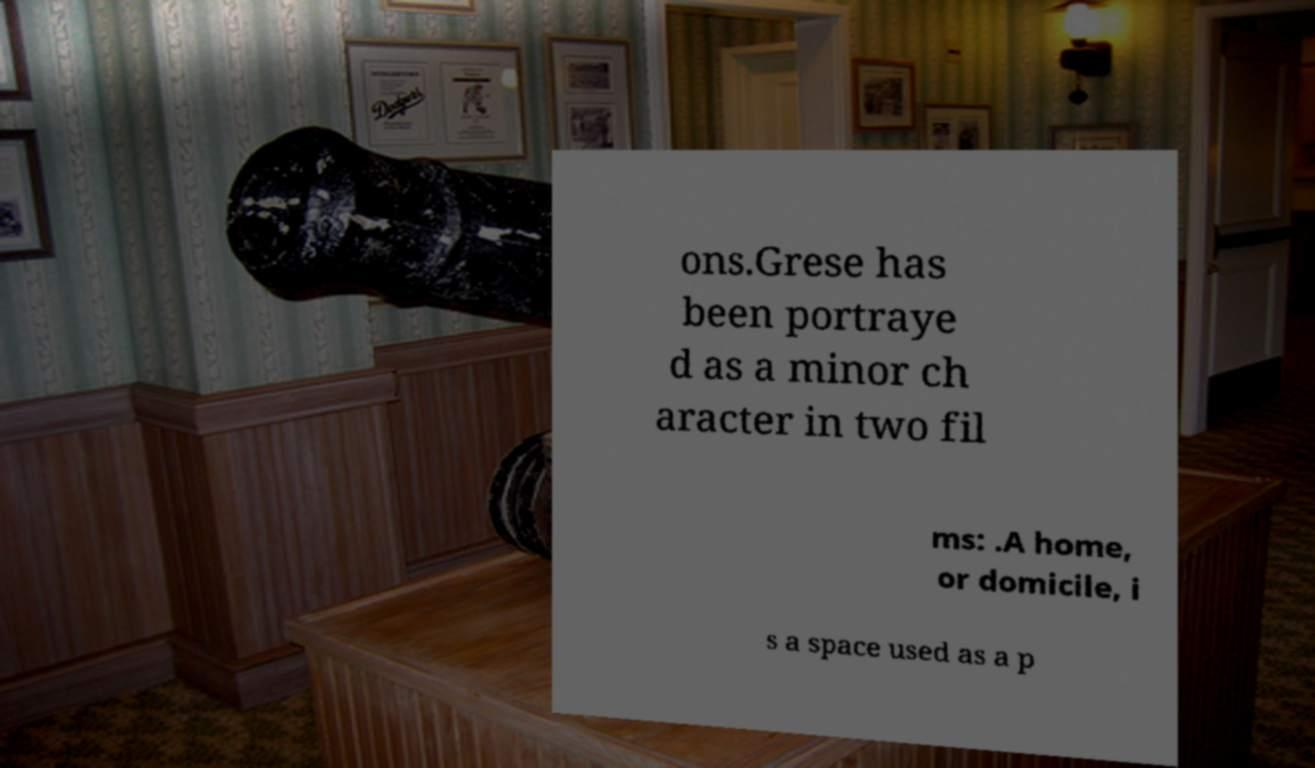Please identify and transcribe the text found in this image. ons.Grese has been portraye d as a minor ch aracter in two fil ms: .A home, or domicile, i s a space used as a p 